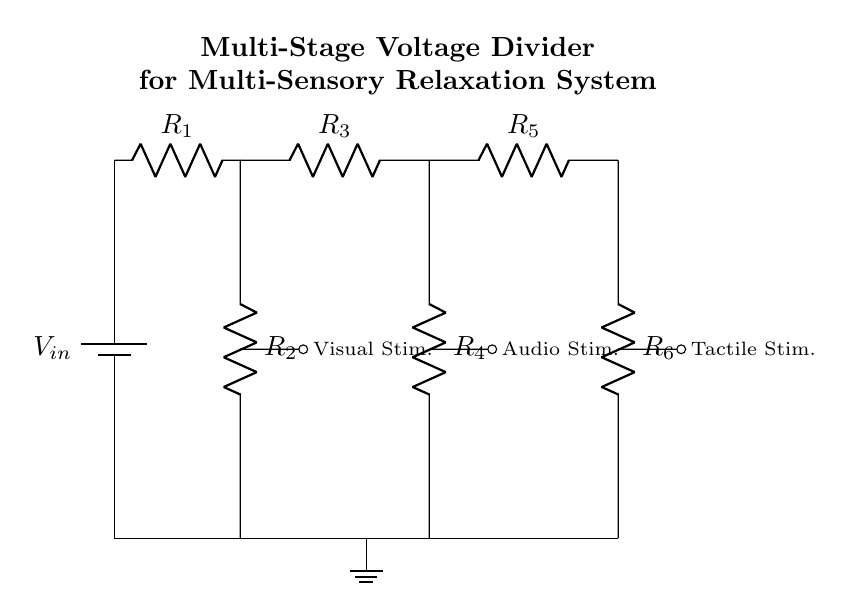What is the input voltage for this circuit? The input voltage, labeled as V_in, is the source voltage supplied to the voltage divider. In the circuit diagram, it is shown at the top and typically represents the voltage at the battery.
Answer: V_in How many resistors are in the first stage of the divider? The first stage consists of two resistors, R1 and R2, connected in series between the input voltage source and ground. This can be observed directly from the diagram where the components are marked.
Answer: 2 What is the function of R3 in the circuit? R3 is the first resistor in the second stage of the voltage divider, affecting the output voltage for audio stimuli. It is connected in series with R4 and helps determine the voltage available for that specific sensory output.
Answer: Audio Stim What is the total number of stages in this voltage divider? The circuit contains three distinct stages, each with two resistors and a specific output for different sensory stimuli (visual, audio, tactile). This can be seen as the groups of resistors lead to different output connections.
Answer: 3 Which resistor is associated with the tactile stimulation? The tactile stimulation is connected to R5 and R6 in the third stage of the voltage divider. This connection is depicted in the diagram where the tactile stim output leads from the junction between these two resistors.
Answer: R5, R6 What happens to the voltage as it passes through each stage? As the voltage passes through each stage of the voltage divider, it decreases proportionally based on the resistance values of the resistors. The voltage drop occurs due to the division of the input voltage across the resistors in series as per Ohm's law.
Answer: It decreases How does this circuit setup benefit group therapy sessions? The multi-stage voltage divider allows for the controlled distribution of voltages to multiple sensory outputs, providing a designed experience for relaxation in group therapy sessions. Each stage can be tailored for specific stimuli, promoting a holistic therapeutic environment.
Answer: Controlled sensory outputs 